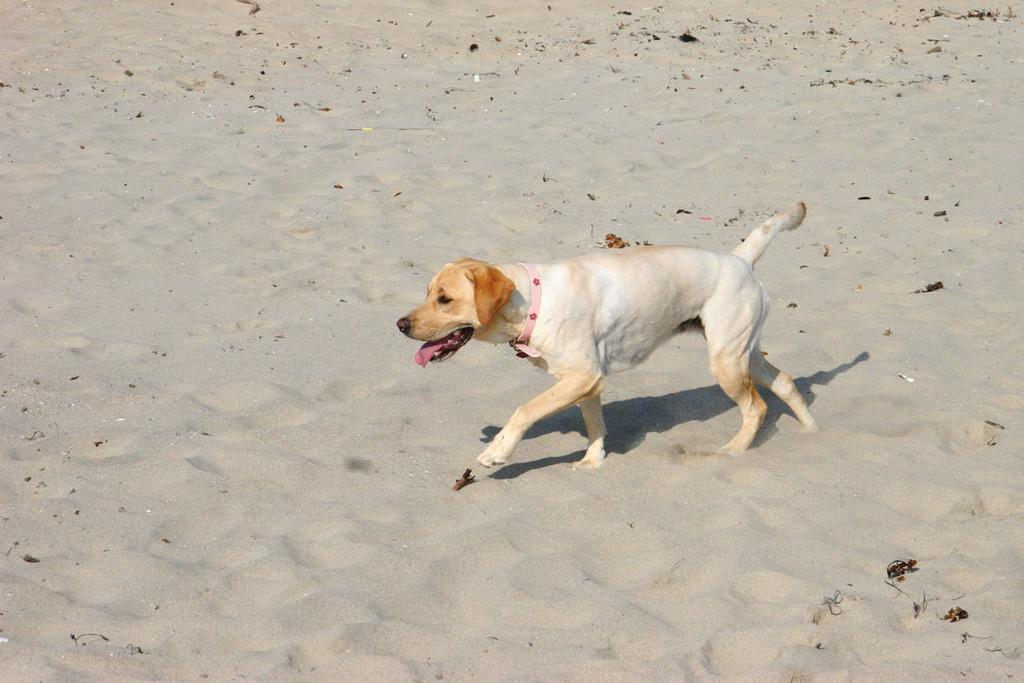What animal is present in the image? There is a dog in the image. What surface is the dog walking on? The dog is walking on the sand. How many chairs are placed on the sand in the image? There are no chairs present in the image; it only features a dog walking on the sand. 